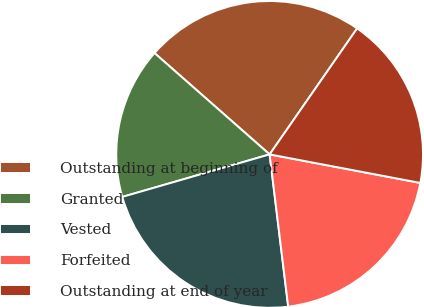<chart> <loc_0><loc_0><loc_500><loc_500><pie_chart><fcel>Outstanding at beginning of<fcel>Granted<fcel>Vested<fcel>Forfeited<fcel>Outstanding at end of year<nl><fcel>23.17%<fcel>15.96%<fcel>22.46%<fcel>20.09%<fcel>18.32%<nl></chart> 